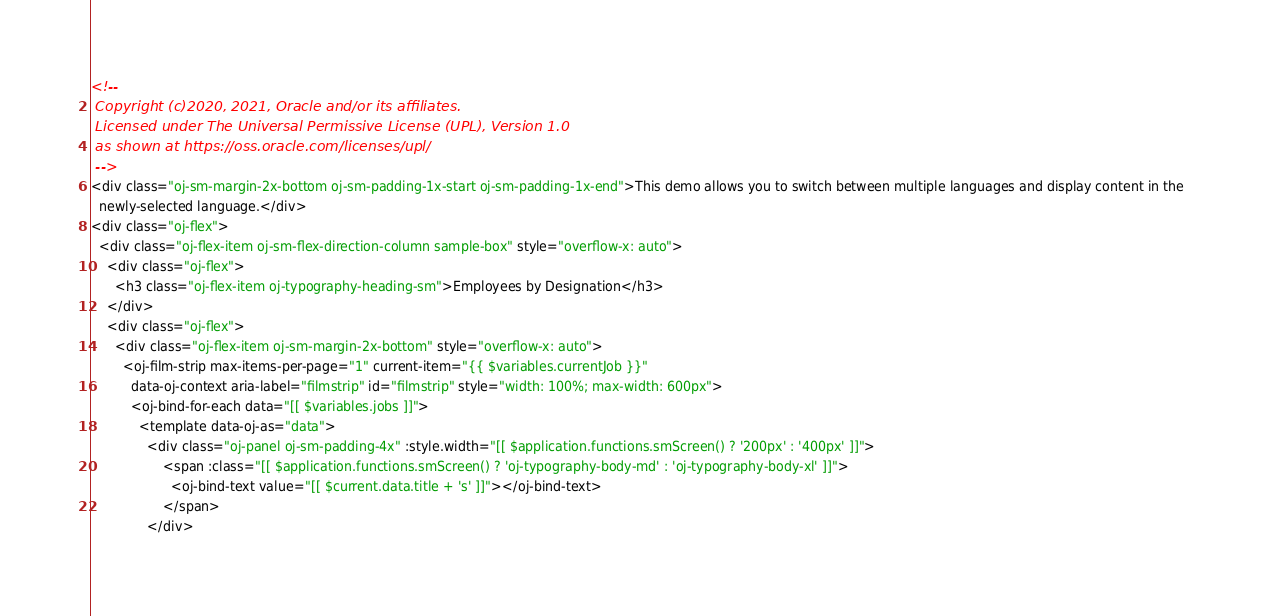Convert code to text. <code><loc_0><loc_0><loc_500><loc_500><_HTML_><!--
 Copyright (c)2020, 2021, Oracle and/or its affiliates.
 Licensed under The Universal Permissive License (UPL), Version 1.0
 as shown at https://oss.oracle.com/licenses/upl/
 -->
<div class="oj-sm-margin-2x-bottom oj-sm-padding-1x-start oj-sm-padding-1x-end">This demo allows you to switch between multiple languages and display content in the
  newly-selected language.</div>
<div class="oj-flex">
  <div class="oj-flex-item oj-sm-flex-direction-column sample-box" style="overflow-x: auto">
    <div class="oj-flex">
      <h3 class="oj-flex-item oj-typography-heading-sm">Employees by Designation</h3>
    </div>
    <div class="oj-flex">
      <div class="oj-flex-item oj-sm-margin-2x-bottom" style="overflow-x: auto">
        <oj-film-strip max-items-per-page="1" current-item="{{ $variables.currentJob }}"
          data-oj-context aria-label="filmstrip" id="filmstrip" style="width: 100%; max-width: 600px">
          <oj-bind-for-each data="[[ $variables.jobs ]]">
            <template data-oj-as="data">
              <div class="oj-panel oj-sm-padding-4x" :style.width="[[ $application.functions.smScreen() ? '200px' : '400px' ]]">
                  <span :class="[[ $application.functions.smScreen() ? 'oj-typography-body-md' : 'oj-typography-body-xl' ]]">
                    <oj-bind-text value="[[ $current.data.title + 's' ]]"></oj-bind-text>
                  </span>
              </div></code> 